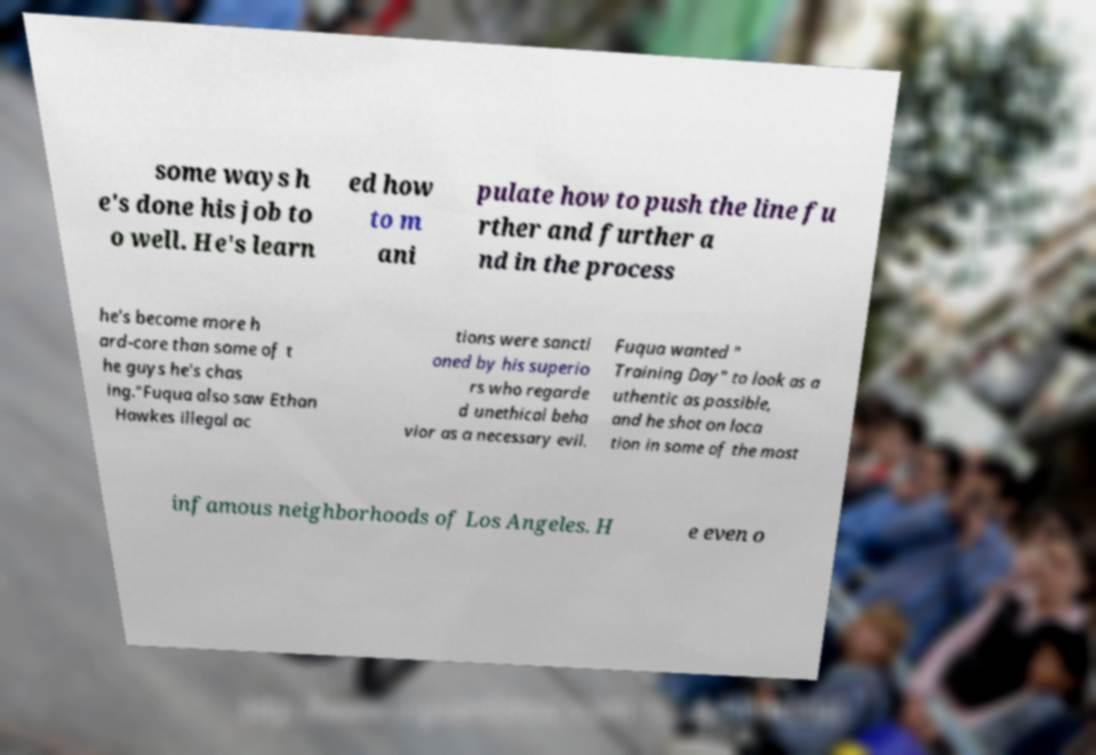I need the written content from this picture converted into text. Can you do that? some ways h e's done his job to o well. He's learn ed how to m ani pulate how to push the line fu rther and further a nd in the process he's become more h ard-core than some of t he guys he's chas ing."Fuqua also saw Ethan Hawkes illegal ac tions were sancti oned by his superio rs who regarde d unethical beha vior as a necessary evil. Fuqua wanted " Training Day" to look as a uthentic as possible, and he shot on loca tion in some of the most infamous neighborhoods of Los Angeles. H e even o 